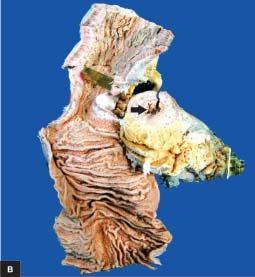what is shown in longitudinal section along with a segment in cross section?
Answer the question using a single word or phrase. Specimen of small intestine 